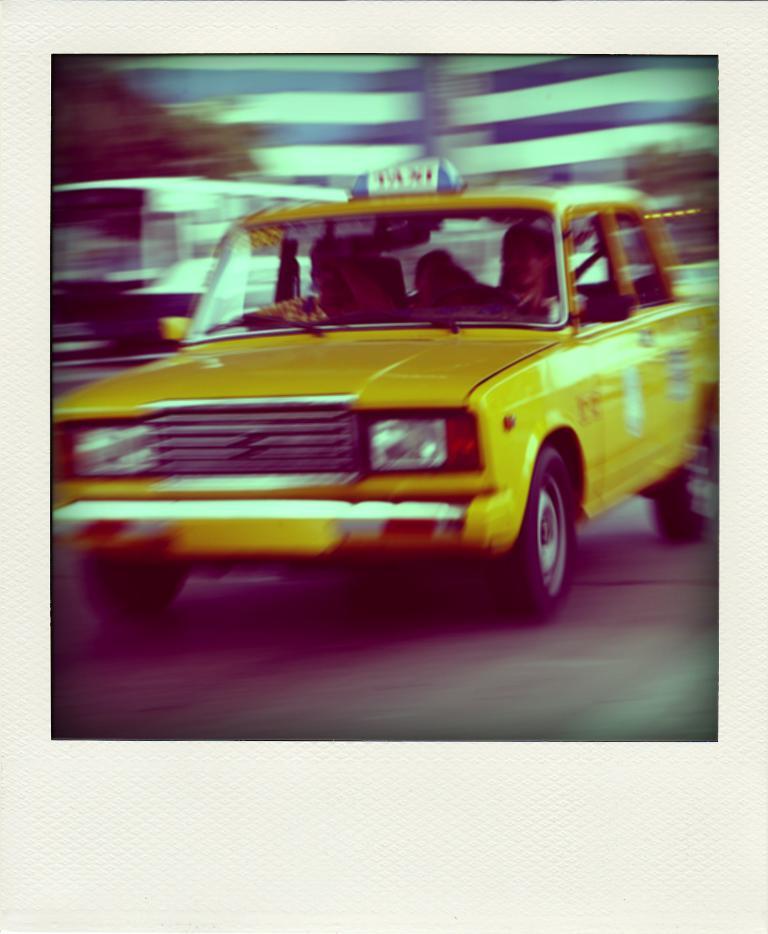What is that car?
Your answer should be very brief. Taxi. 